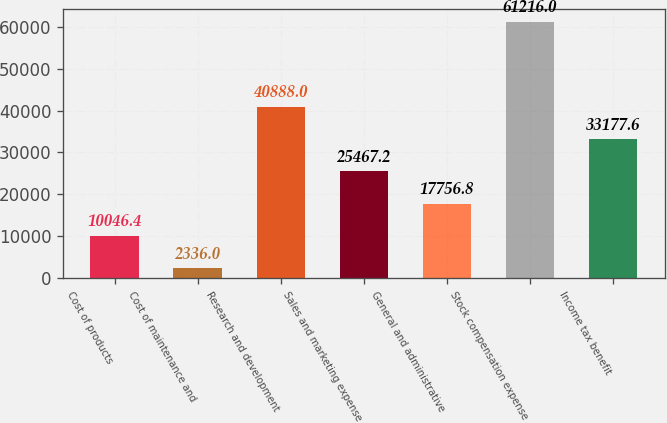Convert chart to OTSL. <chart><loc_0><loc_0><loc_500><loc_500><bar_chart><fcel>Cost of products<fcel>Cost of maintenance and<fcel>Research and development<fcel>Sales and marketing expense<fcel>General and administrative<fcel>Stock compensation expense<fcel>Income tax benefit<nl><fcel>10046.4<fcel>2336<fcel>40888<fcel>25467.2<fcel>17756.8<fcel>61216<fcel>33177.6<nl></chart> 